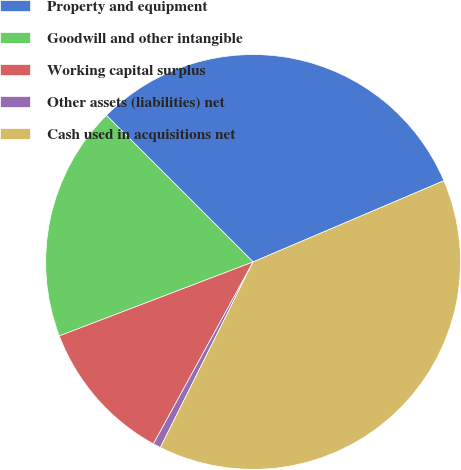<chart> <loc_0><loc_0><loc_500><loc_500><pie_chart><fcel>Property and equipment<fcel>Goodwill and other intangible<fcel>Working capital surplus<fcel>Other assets (liabilities) net<fcel>Cash used in acquisitions net<nl><fcel>31.1%<fcel>18.3%<fcel>11.22%<fcel>0.6%<fcel>38.78%<nl></chart> 